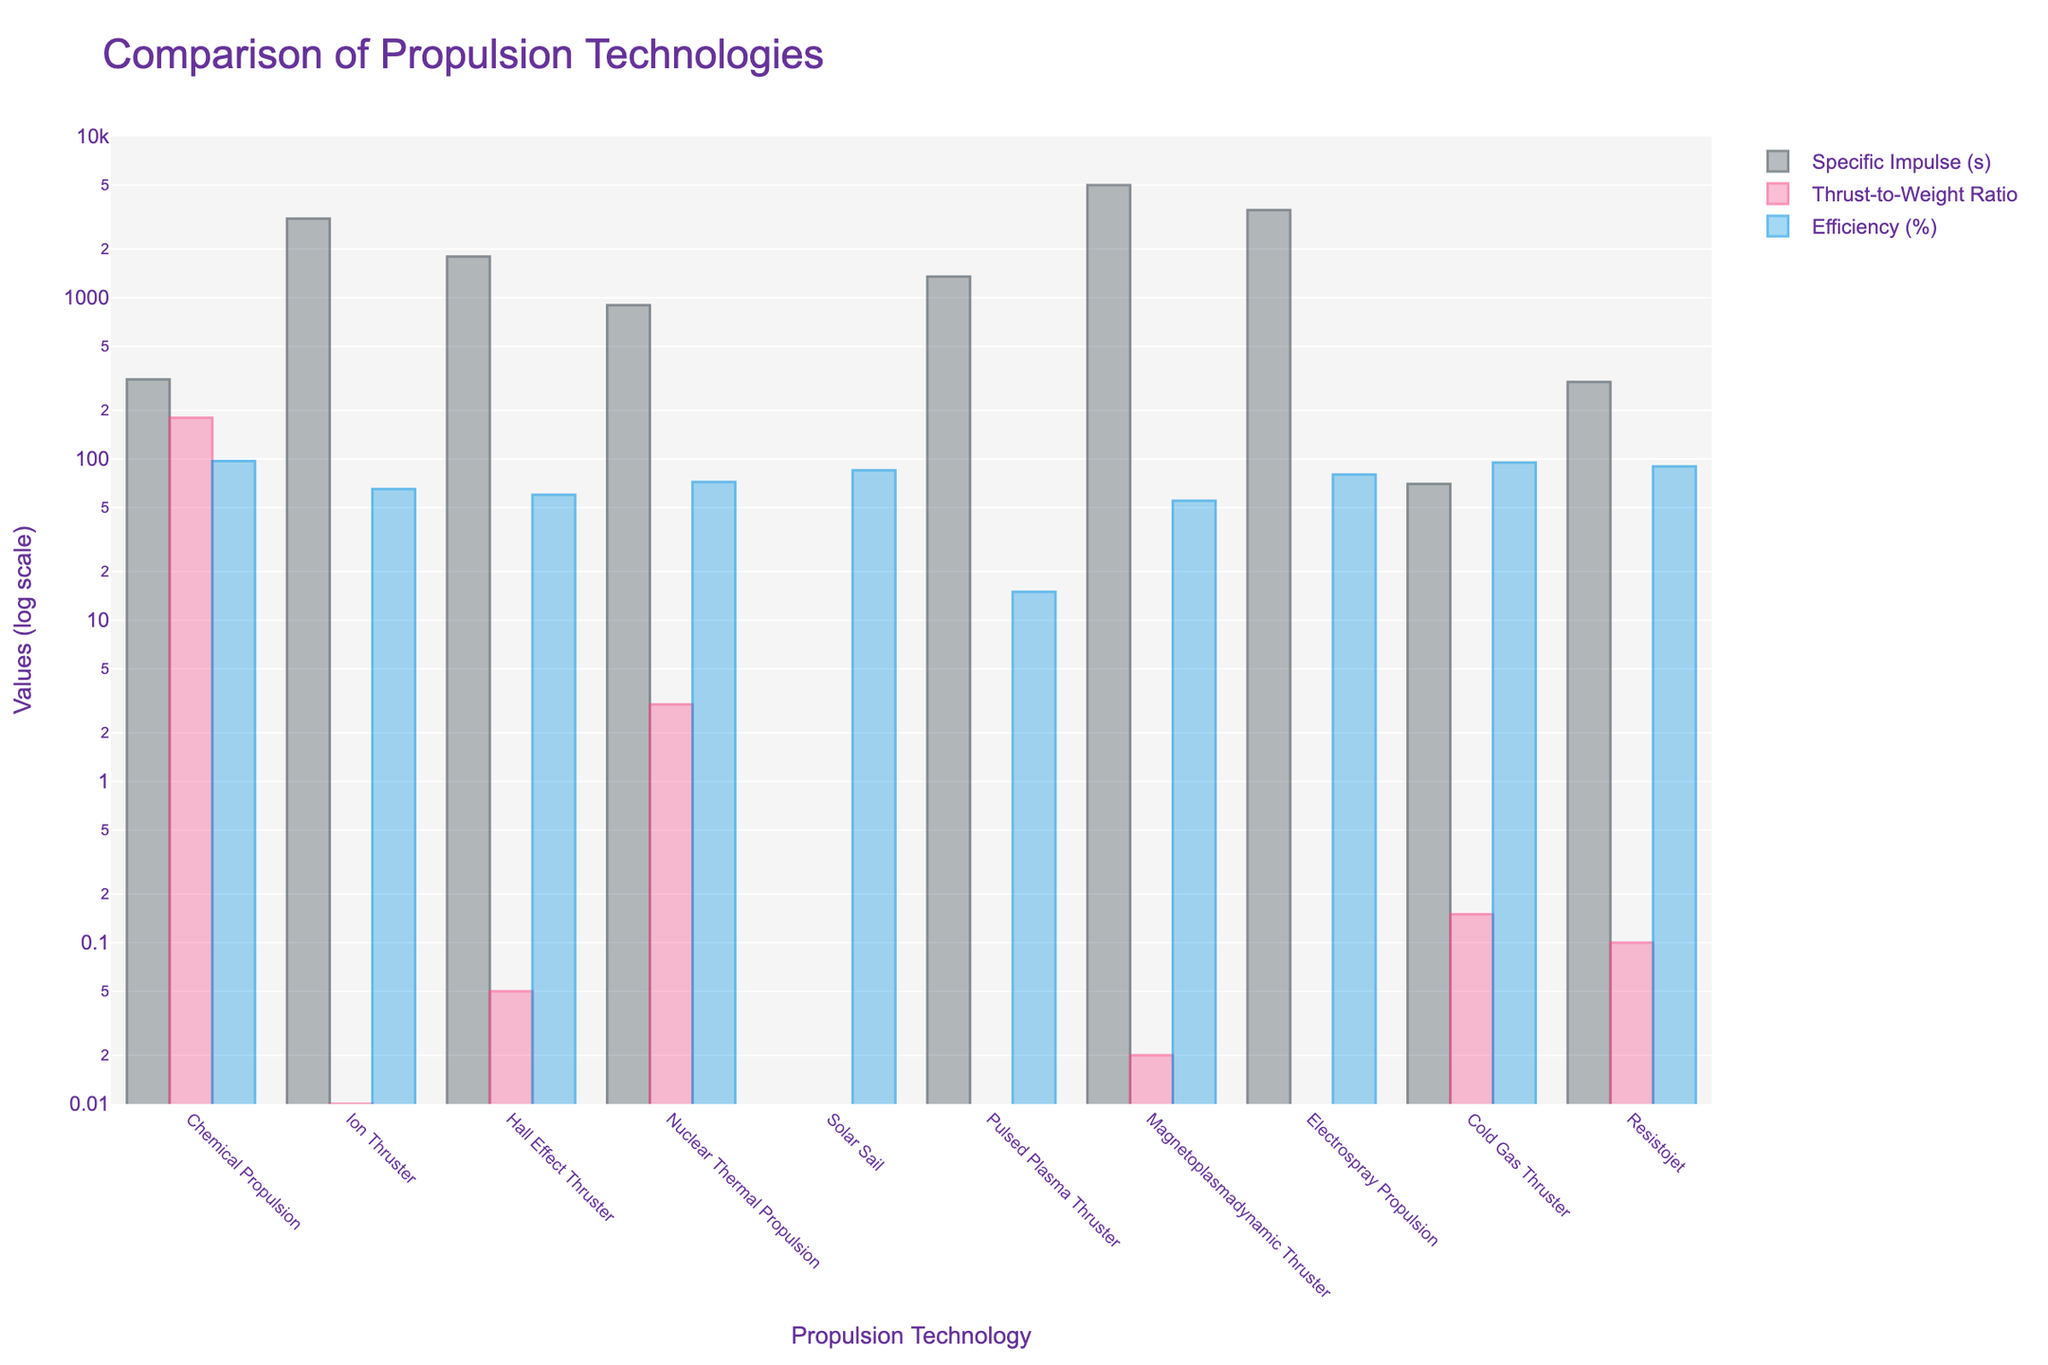What propulsion technology has the highest specific impulse? The Ion Thruster, used in NASA DART, has the highest specific impulse as represented by the tallest bar in "Specific Impulse (s)"
Answer: Ion Thruster Which propulsion technology has the lowest efficiency? The Pulser Plasma Thruster, used in NASA EO-1, has the lowest efficiency. It is indicated by the shortest blue bar in the "Efficiency (%)" section
Answer: Pulser Plasma Thruster Between Chemical Propulsion and Nuclear Thermal Propulsion, which has a higher thrust-to-weight ratio? Chemical Propulsion, used in SpaceX Falcon 9, has a significantly higher thrust-to-weight ratio compared to Nuclear Thermal Propulsion as shown by the taller position of the red bar in "Thrust-to-Weight Ratio"
Answer: Chemical Propulsion How does the efficiency of the Solar Sail compare to that of the Hall Effect Thruster? The efficiency of the Solar Sail is higher than that of the Hall Effect Thruster. This is visualized by the Solar Sail's blue bar being higher than the Hall Effect Thruster's blue bar in the "Efficiency (%)" section
Answer: Solar Sail What's the sum of the thrust-to-weight ratio for the Hall Effect Thruster and Pulsed Plasma Thruster? The thrust-to-weight ratio for Hall Effect Thruster is 0.05, and for Pulsed Plasma Thruster is 0.001. Their sum is 0.05 + 0.001 = 0.051
Answer: 0.051 Which propulsion technology has both Specific Impulse and Efficiency values below 100? The Cold Gas Thruster, used in SpaceX Starlink, has both Specific Impulse (70) and Efficiency (95) values below 100
Answer: Cold Gas Thruster Order the propulsion technologies from highest to lowest in terms of Specific Impulse. The order from highest to lowest in terms of Specific Impulse is: Magnetoplasmadynamic Thruster, Electrospray Propulsion, Ion Thruster, Hall Effect Thruster, Pulsed Plasma Thruster, Nuclear Thermal Propulsion, Chemical Propulsion, Resistojet, Cold Gas Thruster
Answer: Magnetoplasmadynamic Thruster, Electrospray Propulsion, Ion Thruster, Hall Effect Thruster, Pulsed Plasma Thruster, Nuclear Thermal Propulsion, Chemical Propulsion, Resistojet, Cold Gas Thruster 